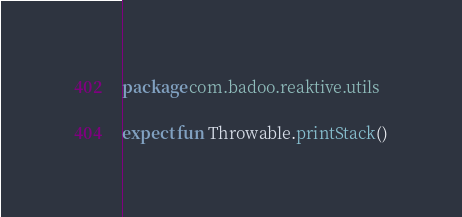Convert code to text. <code><loc_0><loc_0><loc_500><loc_500><_Kotlin_>package com.badoo.reaktive.utils

expect fun Throwable.printStack()
</code> 